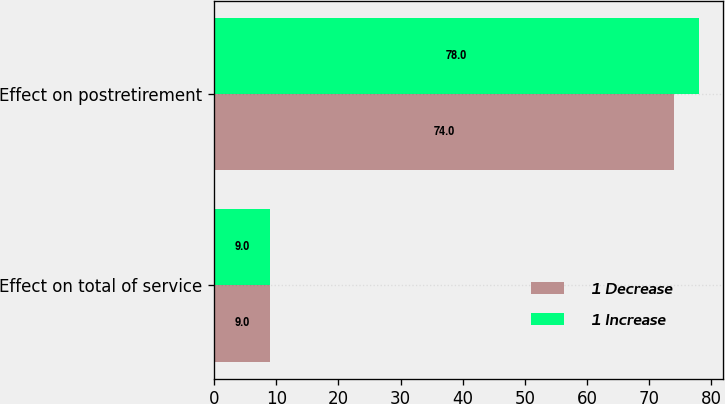Convert chart. <chart><loc_0><loc_0><loc_500><loc_500><stacked_bar_chart><ecel><fcel>Effect on total of service<fcel>Effect on postretirement<nl><fcel>1 Decrease<fcel>9<fcel>74<nl><fcel>1 Increase<fcel>9<fcel>78<nl></chart> 